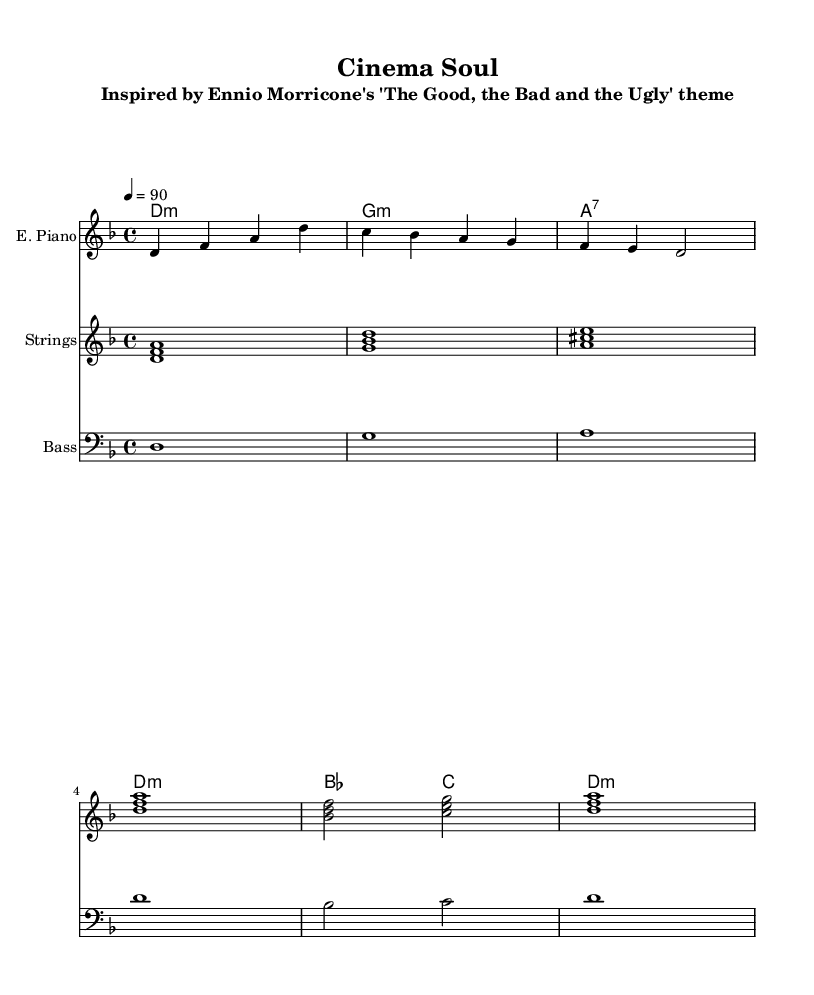What is the key signature of this music? The key signature is D minor, which has one flat (B♭) indicated in the sheet music.
Answer: D minor What is the time signature of this piece? The time signature is 4/4, meaning there are four beats per measure, as shown at the beginning of the sheet music.
Answer: 4/4 What is the tempo marking for this piece? The tempo is indicated as "4=90", which means the quarter note gets 90 beats per minute, allowing performers to understand the pacing required.
Answer: 90 How many measures are there in the electric piano part? By counting the number of distinct groupings shown in the electric piano part, there are six measures, each separated by vertical lines.
Answer: 6 What chord is played in the first measure of the strings? In the first measure, the chord played is D minor, indicated by the notes D, F, and A being played together.
Answer: D minor What is the highest note in the bass part? The highest note in the bass part is D, given that all notes occur in a relatively low range but only reaches up to D in the sequence provided.
Answer: D What type of chords are predominantly used in this piece? The chords found in the chord section are minor chords and one dominant seventh chord, indicative of the harmonic structure typical in R&B music.
Answer: Minor chords 